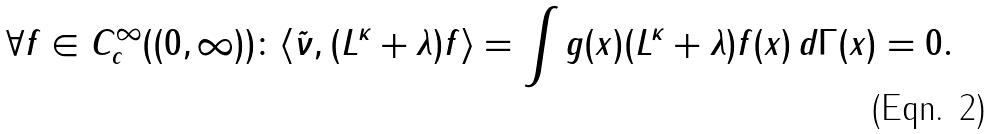Convert formula to latex. <formula><loc_0><loc_0><loc_500><loc_500>\forall f \in C ^ { \infty } _ { c } ( ( 0 , \infty ) ) \colon \langle \tilde { \nu } , ( L ^ { \kappa } + \lambda ) f \rangle = \int g ( x ) ( L ^ { \kappa } + \lambda ) f ( x ) \, d \Gamma ( x ) = 0 .</formula> 